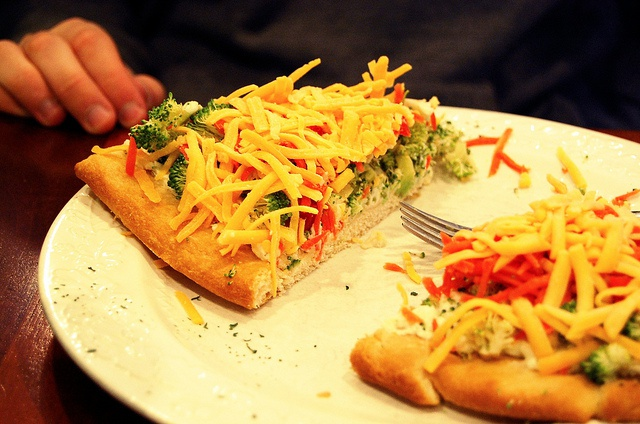Describe the objects in this image and their specific colors. I can see pizza in black, orange, gold, and red tones, pizza in black, orange, red, and gold tones, people in black, red, brown, and maroon tones, broccoli in black, olive, and orange tones, and broccoli in black, orange, olive, and gold tones in this image. 